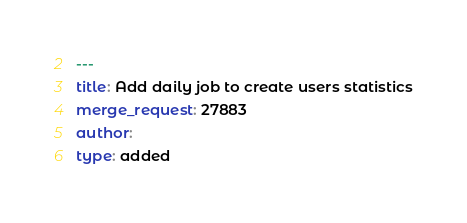Convert code to text. <code><loc_0><loc_0><loc_500><loc_500><_YAML_>---
title: Add daily job to create users statistics
merge_request: 27883
author:
type: added
</code> 